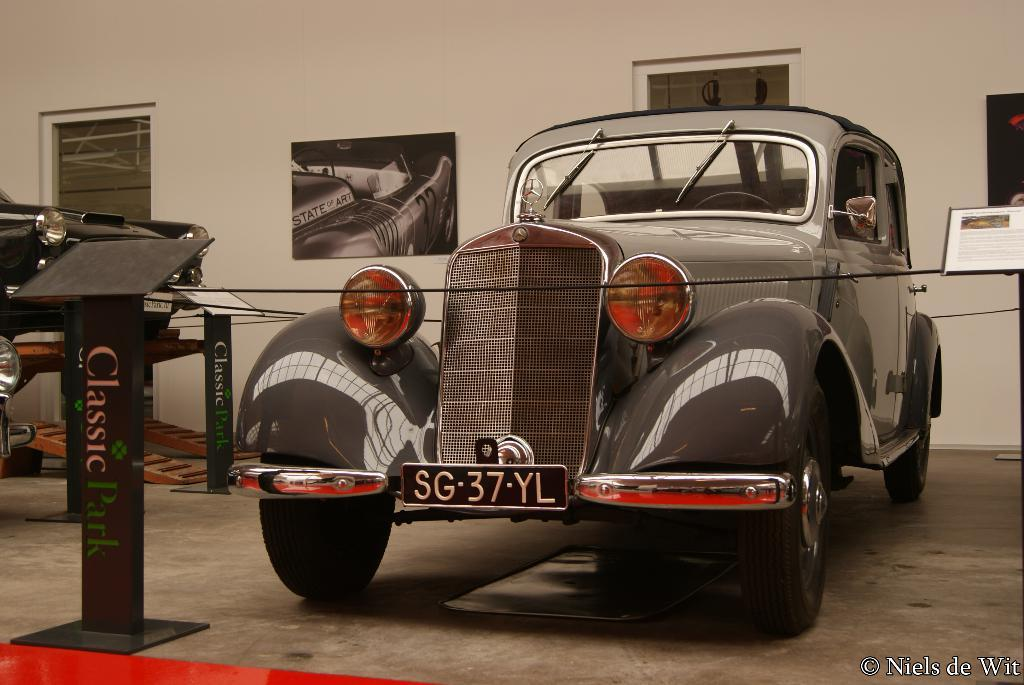What type of structure can be seen in the image? There is a wall in the image. What feature is present in the wall? There is a window in the image. What decorative elements are visible on the wall? There are posters in the image. What type of vehicles can be seen in the image? There are cars in the image. What is the color of the mat in the front of the image? There is a red color mat in the front of the image. What type of yoke is being used to control the cars in the image? There is no yoke present in the image, and the cars are not being controlled by any yoke. What time of day is depicted in the image? The time of day cannot be determined from the image, as there are no specific indicators of time. 